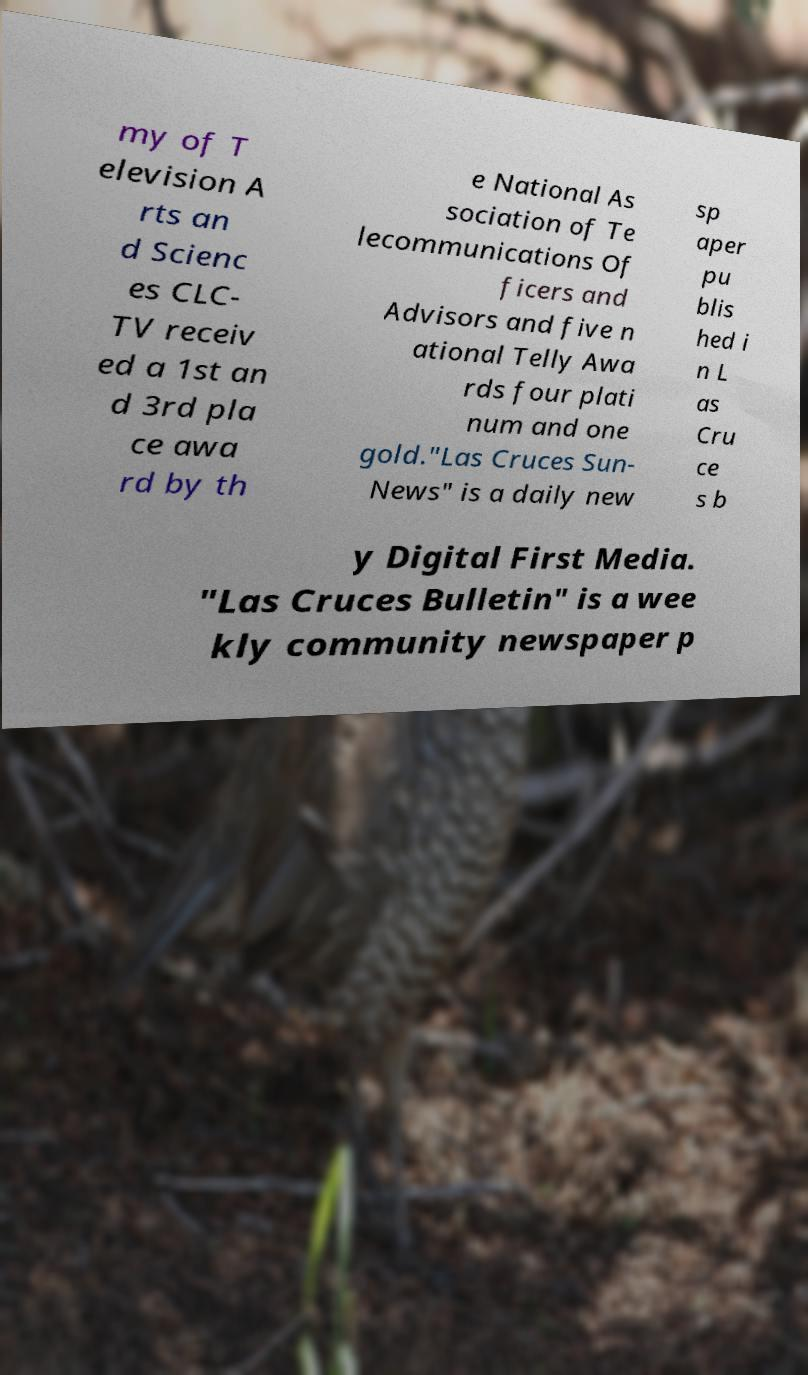Could you assist in decoding the text presented in this image and type it out clearly? my of T elevision A rts an d Scienc es CLC- TV receiv ed a 1st an d 3rd pla ce awa rd by th e National As sociation of Te lecommunications Of ficers and Advisors and five n ational Telly Awa rds four plati num and one gold."Las Cruces Sun- News" is a daily new sp aper pu blis hed i n L as Cru ce s b y Digital First Media. "Las Cruces Bulletin" is a wee kly community newspaper p 